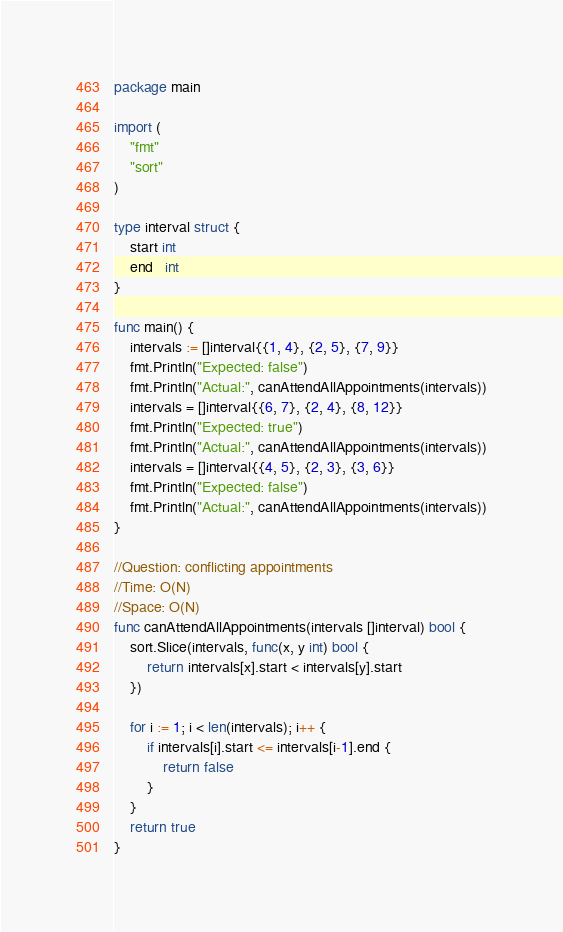Convert code to text. <code><loc_0><loc_0><loc_500><loc_500><_Go_>package main

import (
	"fmt"
	"sort"
)

type interval struct {
	start int
	end   int
}

func main() {
	intervals := []interval{{1, 4}, {2, 5}, {7, 9}}
	fmt.Println("Expected: false")
	fmt.Println("Actual:", canAttendAllAppointments(intervals))
	intervals = []interval{{6, 7}, {2, 4}, {8, 12}}
	fmt.Println("Expected: true")
	fmt.Println("Actual:", canAttendAllAppointments(intervals))
	intervals = []interval{{4, 5}, {2, 3}, {3, 6}}
	fmt.Println("Expected: false")
	fmt.Println("Actual:", canAttendAllAppointments(intervals))
}

//Question: conflicting appointments
//Time: O(N)
//Space: O(N)
func canAttendAllAppointments(intervals []interval) bool {
	sort.Slice(intervals, func(x, y int) bool {
		return intervals[x].start < intervals[y].start
	})

	for i := 1; i < len(intervals); i++ {
		if intervals[i].start <= intervals[i-1].end {
			return false
		}
	}
	return true
}
</code> 